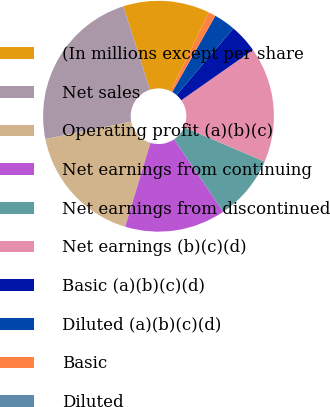<chart> <loc_0><loc_0><loc_500><loc_500><pie_chart><fcel>(In millions except per share<fcel>Net sales<fcel>Operating profit (a)(b)(c)<fcel>Net earnings from continuing<fcel>Net earnings from discontinued<fcel>Net earnings (b)(c)(d)<fcel>Basic (a)(b)(c)(d)<fcel>Diluted (a)(b)(c)(d)<fcel>Basic<fcel>Diluted<nl><fcel>12.12%<fcel>23.23%<fcel>17.17%<fcel>14.14%<fcel>9.09%<fcel>16.16%<fcel>4.04%<fcel>3.03%<fcel>1.01%<fcel>0.0%<nl></chart> 